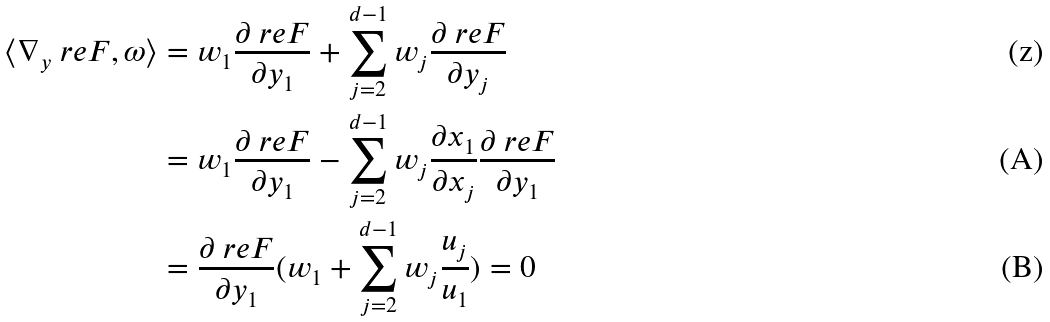<formula> <loc_0><loc_0><loc_500><loc_500>\langle \nabla _ { y } \ r e F , \omega \rangle & = w _ { 1 } \frac { \partial \ r e F } { \partial y _ { 1 } } + \sum _ { j = 2 } ^ { d - 1 } w _ { j } \frac { \partial \ r e F } { \partial y _ { j } } \\ & = w _ { 1 } \frac { \partial \ r e F } { \partial y _ { 1 } } - \sum _ { j = 2 } ^ { d - 1 } w _ { j } \frac { \partial x _ { 1 } } { \partial x _ { j } } \frac { \partial \ r e F } { \partial y _ { 1 } } \\ & = \frac { \partial \ r e F } { \partial y _ { 1 } } ( w _ { 1 } + \sum _ { j = 2 } ^ { d - 1 } w _ { j } \frac { u _ { j } } { u _ { 1 } } ) = 0</formula> 